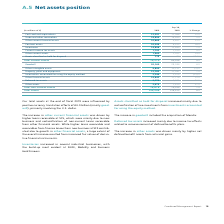According to Siemens Ag's financial document, What caused the increase in the other financial assets? The increase in other current financial assets was driven by higher loans receivable at SFS, which were mainly due to new business and reclassification of non-current loans receivable from other financial assets.. The document states: "The increase in other current financial assets was driven by higher loans receivable at SFS, which were mainly due to new business and reclassificatio..." Also, What caused the increase in the inventories? Inventories increased in several industrial businesses, with the build-up most evident at SGRE, Mobility and Siemens Healthineers.. The document states: "Inventories increased in several industrial businesses, with the build-up most evident at SGRE, Mobility and Siemens Healthineers...." Also, What caused the deferred tax assets to increase? Deferred tax assets increased mainly due to income tax effects related to remeasurement of defined benefits plans.. The document states: "Deferred tax assets increased mainly due to income tax effects related to remeasurement of defined benefits plans...." Also, can you calculate: What was the average inventories in 2019 and 2018? To answer this question, I need to perform calculations using the financial data. The calculation is: (14,806 + 13,885) / 2, which equals 14345.5 (in millions). This is based on the information: "Inventories 14,806 13,885 7 % Inventories 14,806 13,885 7 %..." The key data points involved are: 13,885, 14,806. Also, can you calculate: What is the increase / (decrease) in other current assets from 2018 to 2019? Based on the calculation: 1,960 - 1,707, the result is 253 (in millions). This is based on the information: "Other current assets 1,960 1,707 15 % Other current assets 1,960 1,707 15 %..." The key data points involved are: 1,707, 1,960. Also, can you calculate: What is the increase / (decrease) in total assets from 2018 to 2019? Based on the calculation: 150,248 - 138,915, the result is 11333 (in millions). This is based on the information: "Total assets 150,248 138,915 8 % Total assets 150,248 138,915 8 %..." The key data points involved are: 138,915, 150,248. 